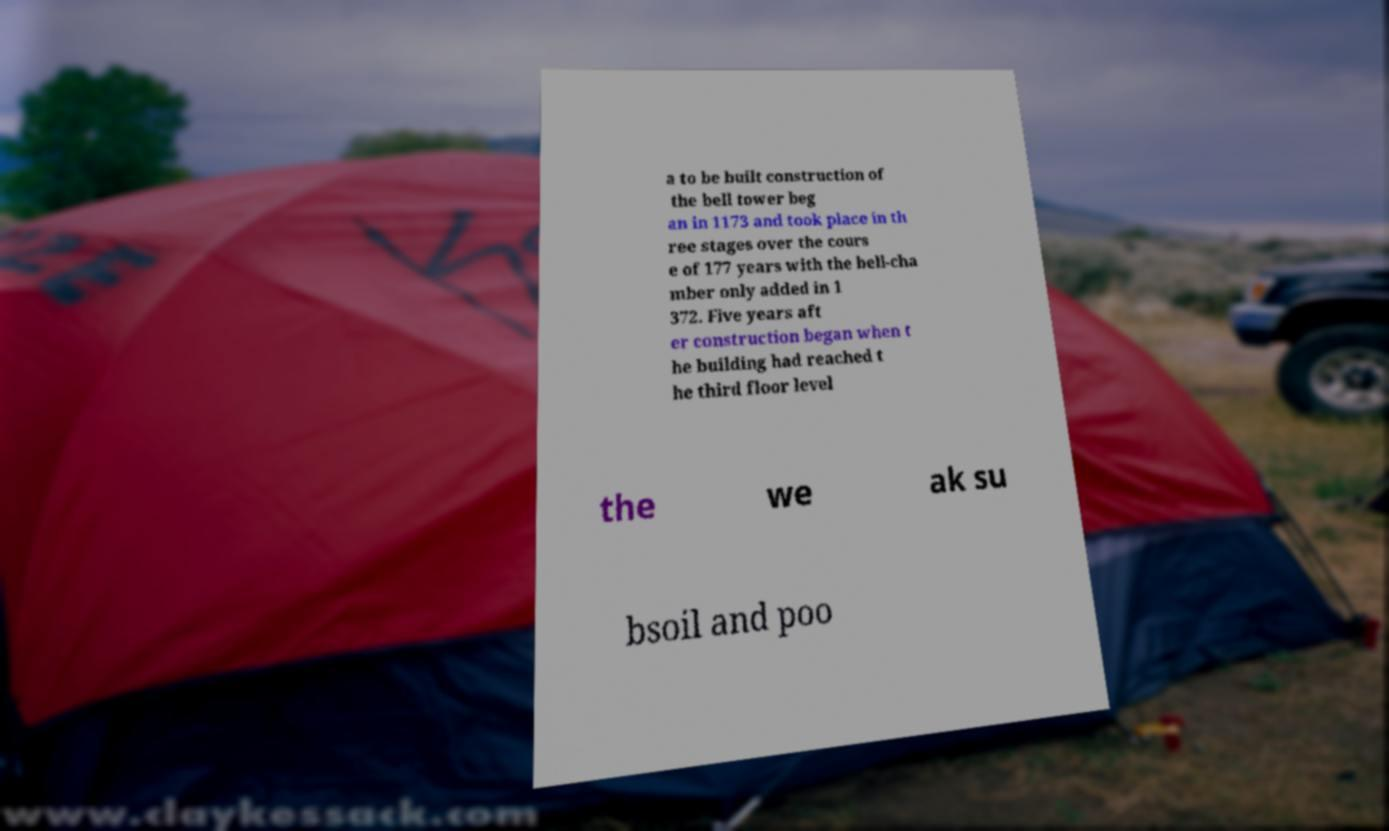Could you extract and type out the text from this image? a to be built construction of the bell tower beg an in 1173 and took place in th ree stages over the cours e of 177 years with the bell-cha mber only added in 1 372. Five years aft er construction began when t he building had reached t he third floor level the we ak su bsoil and poo 